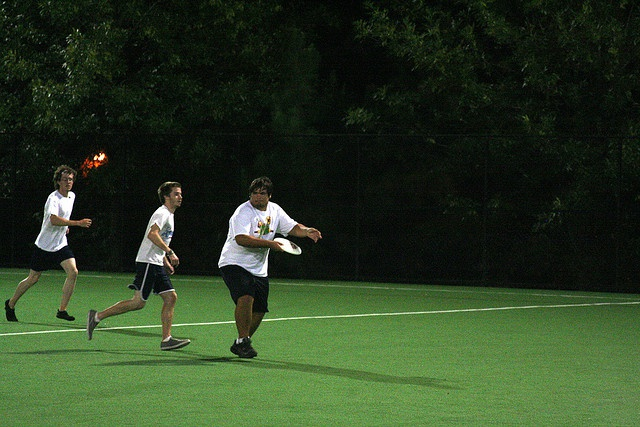Describe the objects in this image and their specific colors. I can see people in black, lavender, darkgray, and maroon tones, people in black, darkgreen, gray, and white tones, people in black, white, olive, and gray tones, and frisbee in black, ivory, gray, and darkgray tones in this image. 